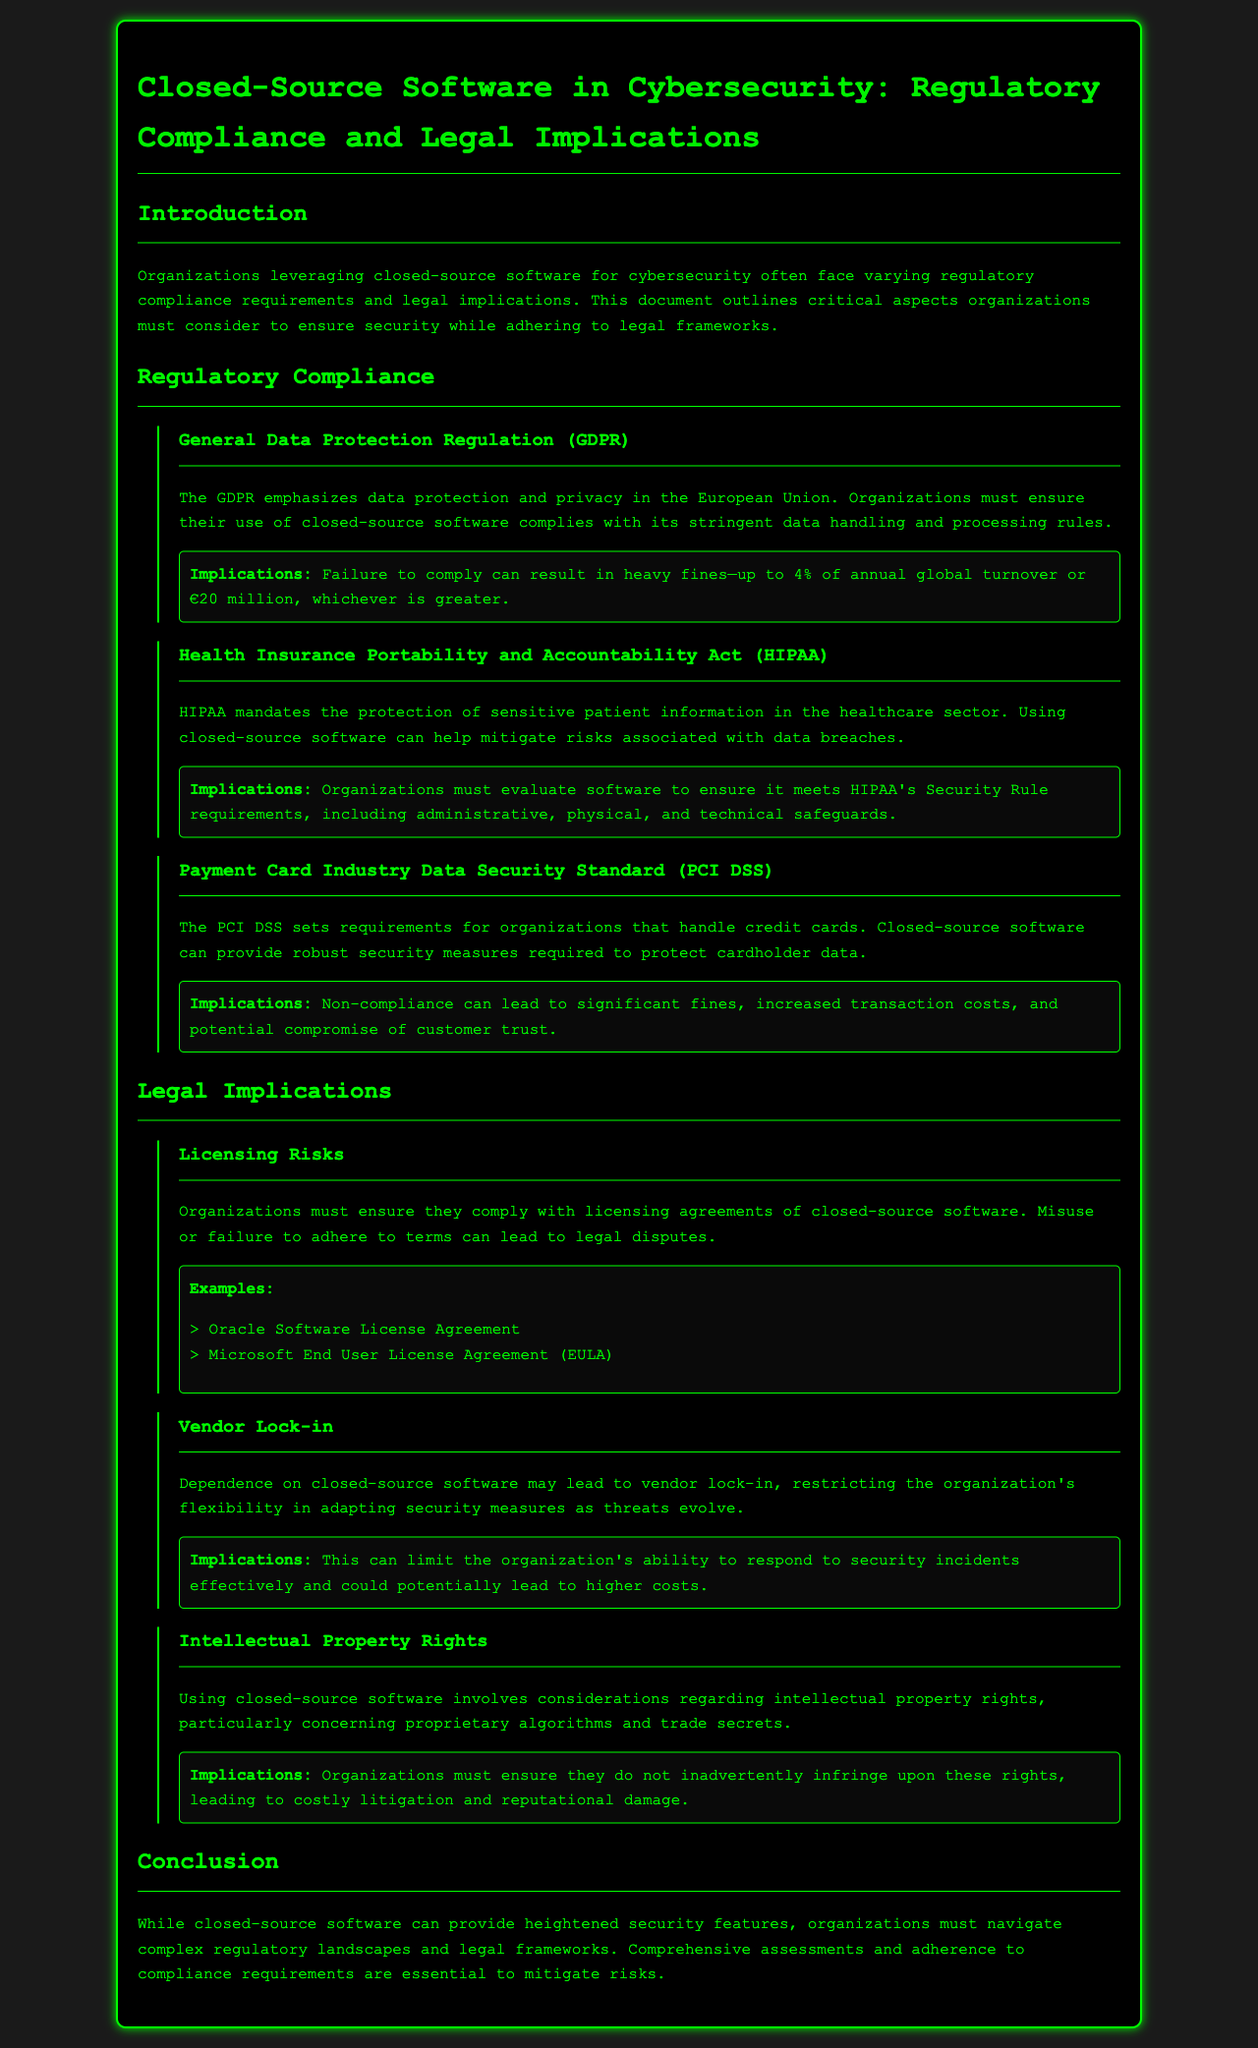What is the title of the document? The title is stated in the header of the document, which clearly identifies the subject matter.
Answer: Closed-Source Software in Cybersecurity: Regulatory Compliance and Legal Implications What regulation is emphasized for protecting patient information? The document highlights a specific regulation within the healthcare sector that focuses on the security of patient data.
Answer: Health Insurance Portability and Accountability Act (HIPAA) What is the maximum fine under GDPR for non-compliance? The document details the potential financial penalties for failing to comply with GDPR regulations.
Answer: Up to 4% of annual global turnover or €20 million, whichever is greater What kind of risks do organizations face with licensing agreements for closed-source software? The section discusses the legal ramifications concerning use and misuse of software licenses.
Answer: Legal disputes Which standard is associated with handling credit card data? The document references a specific standard that organizations must meet if they deal with credit card transactions.
Answer: Payment Card Industry Data Security Standard (PCI DSS) How can closed-source software affect an organization's flexibility? The content explores a particular challenge that may arise from dependence on closed-source solutions.
Answer: Vendor lock-in What kind of protection does HIPAA require for software? The document addresses specific security measures required by HIPAA for protecting sensitive information.
Answer: Administrative, physical, and technical safeguards What is a primary implication of intellectual property rights mentioned? The text discusses a potential legal consequence organizations must be wary of regarding proprietary software.
Answer: Costly litigation and reputational damage 